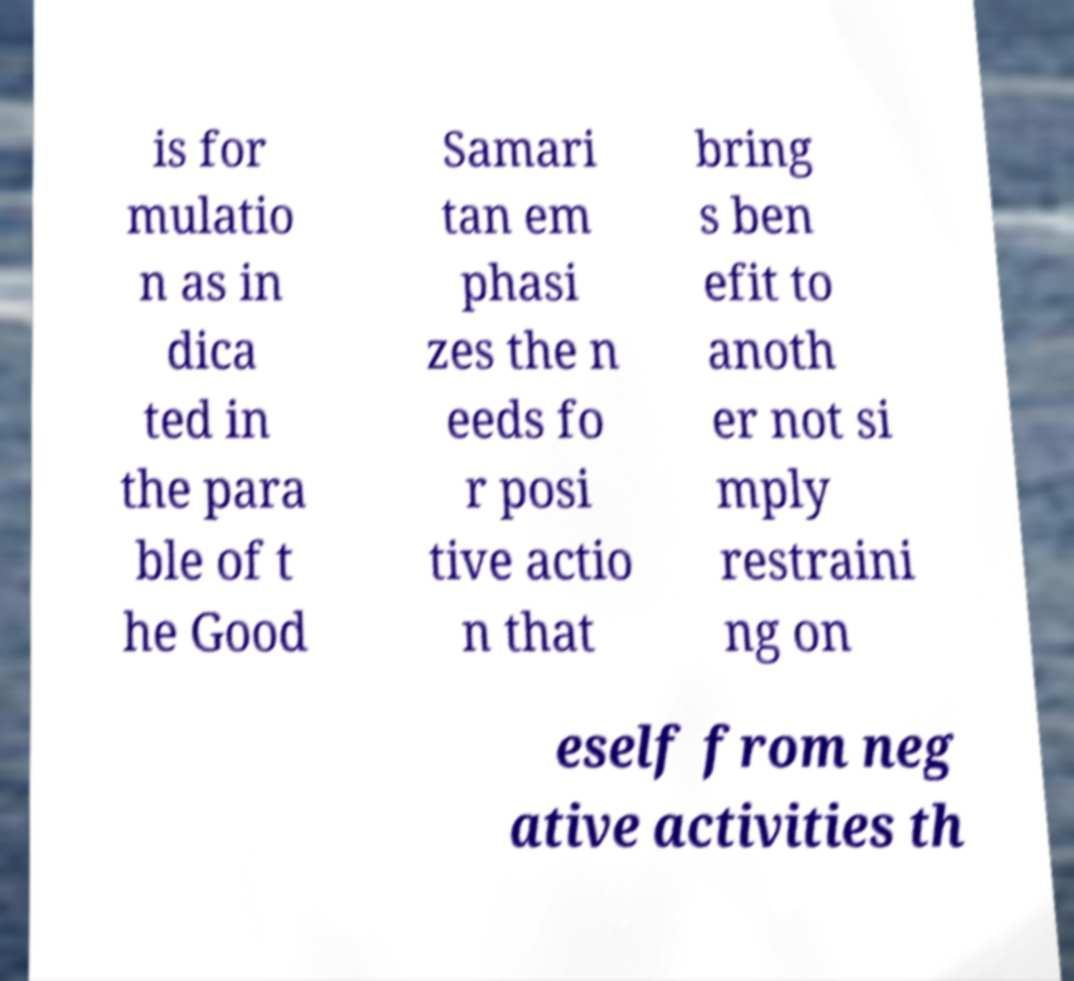Can you accurately transcribe the text from the provided image for me? is for mulatio n as in dica ted in the para ble of t he Good Samari tan em phasi zes the n eeds fo r posi tive actio n that bring s ben efit to anoth er not si mply restraini ng on eself from neg ative activities th 